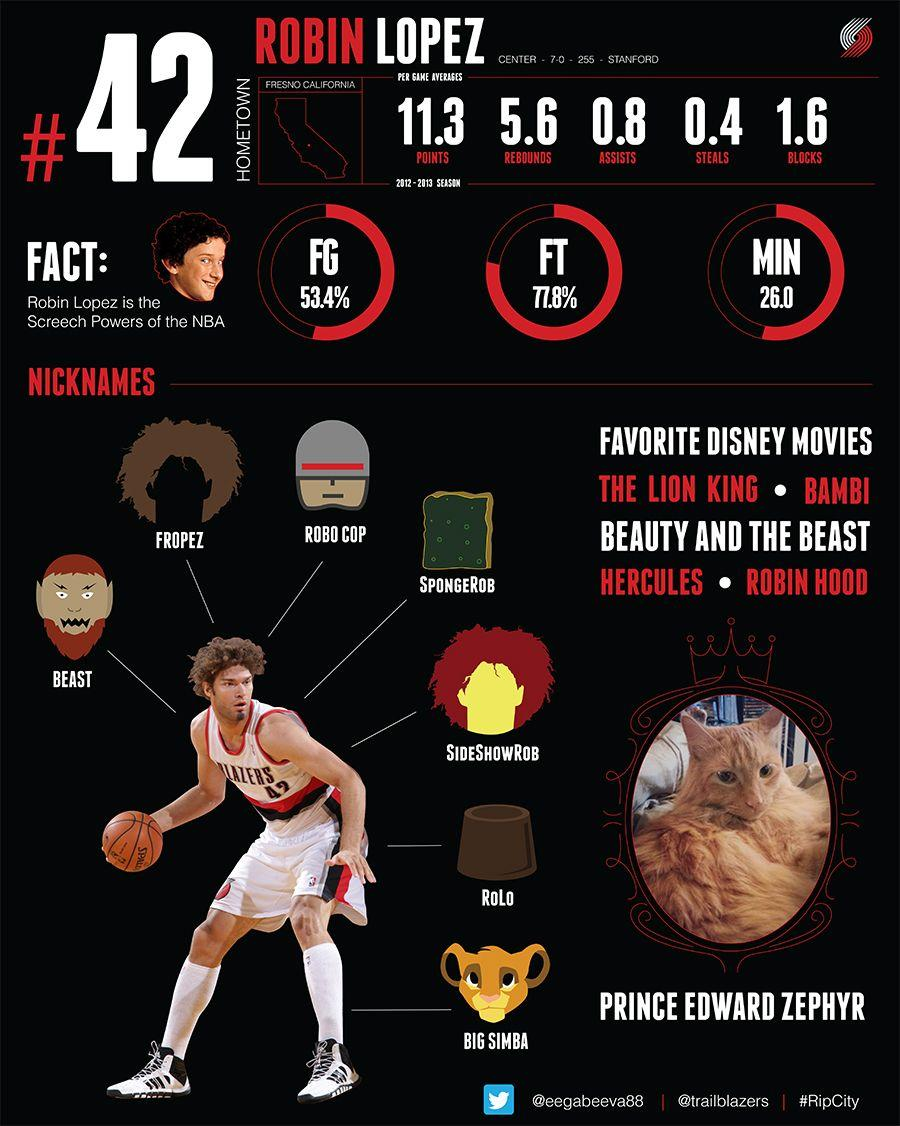Mention a couple of crucial points in this snapshot. I, [person], refer to the nickname "Big Simba" with a lion head as [nickname]. The hometown of Robin Lopez is Fresno, California. Approximately 5 movies have been listed as favorites. Robin Lopez has seven nicknames. The cat's name is Prince Edward Zephyr. 